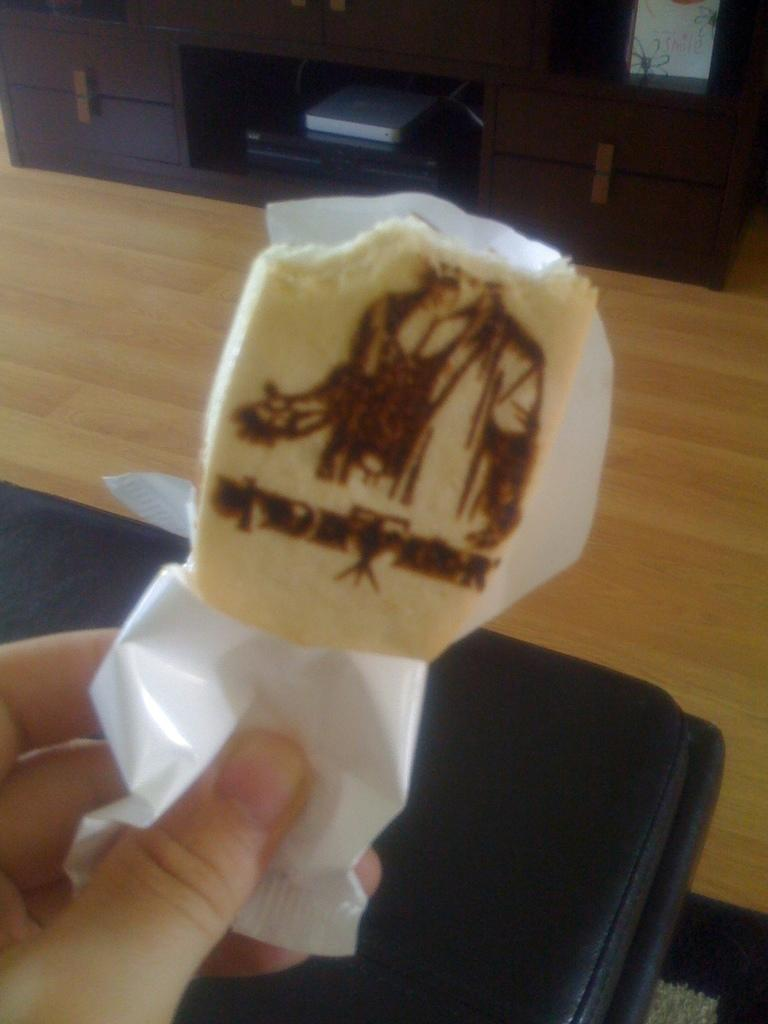What is being held by the person's hand in the image? There is a person's hand holding a chocolate in the image. What is located at the bottom of the image? There is a floor mat at the bottom of the image. What can be seen in the background of the image? There is a stand in the background of the image. What is placed on the stand in the background of the image? There are things placed in the stand in the background of the image. What type of cough medicine is being offered by the person in the image? There is no cough medicine or person visible in the image; it only shows a hand holding a chocolate. What type of chicken is being prepared on the stand in the image? There is no chicken or preparation of food visible in the image; it only shows a stand with things placed on it. 